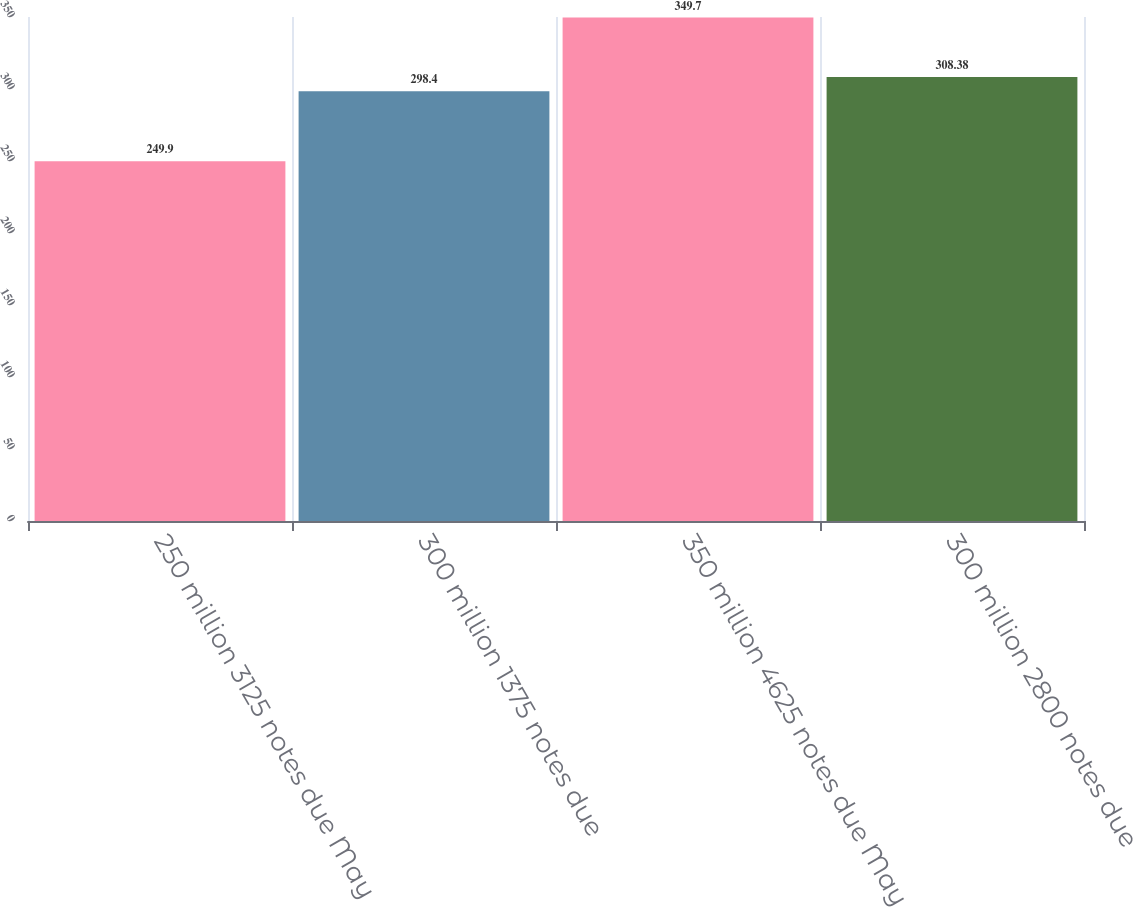Convert chart. <chart><loc_0><loc_0><loc_500><loc_500><bar_chart><fcel>250 million 3125 notes due May<fcel>300 million 1375 notes due<fcel>350 million 4625 notes due May<fcel>300 million 2800 notes due<nl><fcel>249.9<fcel>298.4<fcel>349.7<fcel>308.38<nl></chart> 